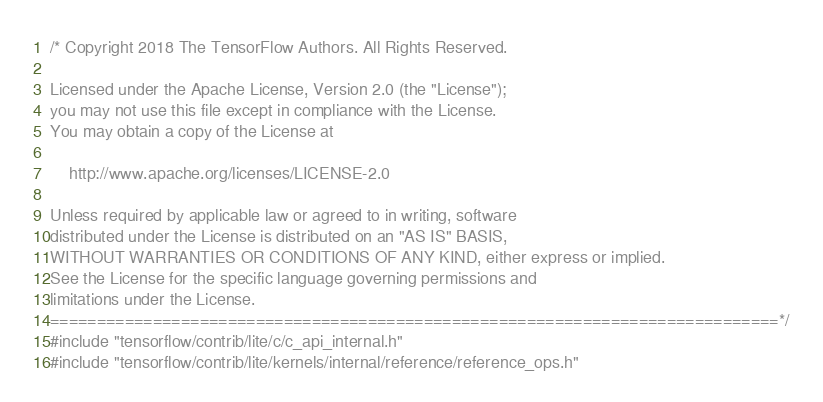Convert code to text. <code><loc_0><loc_0><loc_500><loc_500><_C++_>/* Copyright 2018 The TensorFlow Authors. All Rights Reserved.

Licensed under the Apache License, Version 2.0 (the "License");
you may not use this file except in compliance with the License.
You may obtain a copy of the License at

    http://www.apache.org/licenses/LICENSE-2.0

Unless required by applicable law or agreed to in writing, software
distributed under the License is distributed on an "AS IS" BASIS,
WITHOUT WARRANTIES OR CONDITIONS OF ANY KIND, either express or implied.
See the License for the specific language governing permissions and
limitations under the License.
==============================================================================*/
#include "tensorflow/contrib/lite/c/c_api_internal.h"
#include "tensorflow/contrib/lite/kernels/internal/reference/reference_ops.h"</code> 